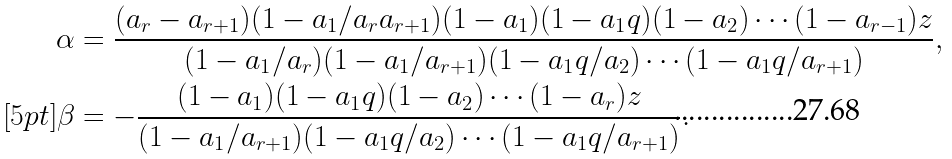<formula> <loc_0><loc_0><loc_500><loc_500>\alpha & = \frac { ( a _ { r } - a _ { r + 1 } ) ( 1 - a _ { 1 } / a _ { r } a _ { r + 1 } ) ( 1 - a _ { 1 } ) ( 1 - a _ { 1 } q ) ( 1 - a _ { 2 } ) \cdots ( 1 - a _ { r - 1 } ) z } { ( 1 - a _ { 1 } / a _ { r } ) ( 1 - a _ { 1 } / a _ { r + 1 } ) ( 1 - a _ { 1 } q / a _ { 2 } ) \cdots ( 1 - a _ { 1 } q / a _ { r + 1 } ) } , \\ [ 5 p t ] \beta & = - \frac { ( 1 - a _ { 1 } ) ( 1 - a _ { 1 } q ) ( 1 - a _ { 2 } ) \cdots ( 1 - a _ { r } ) z } { ( 1 - a _ { 1 } / a _ { r + 1 } ) ( 1 - a _ { 1 } q / a _ { 2 } ) \cdots ( 1 - a _ { 1 } q / a _ { r + 1 } ) } .</formula> 